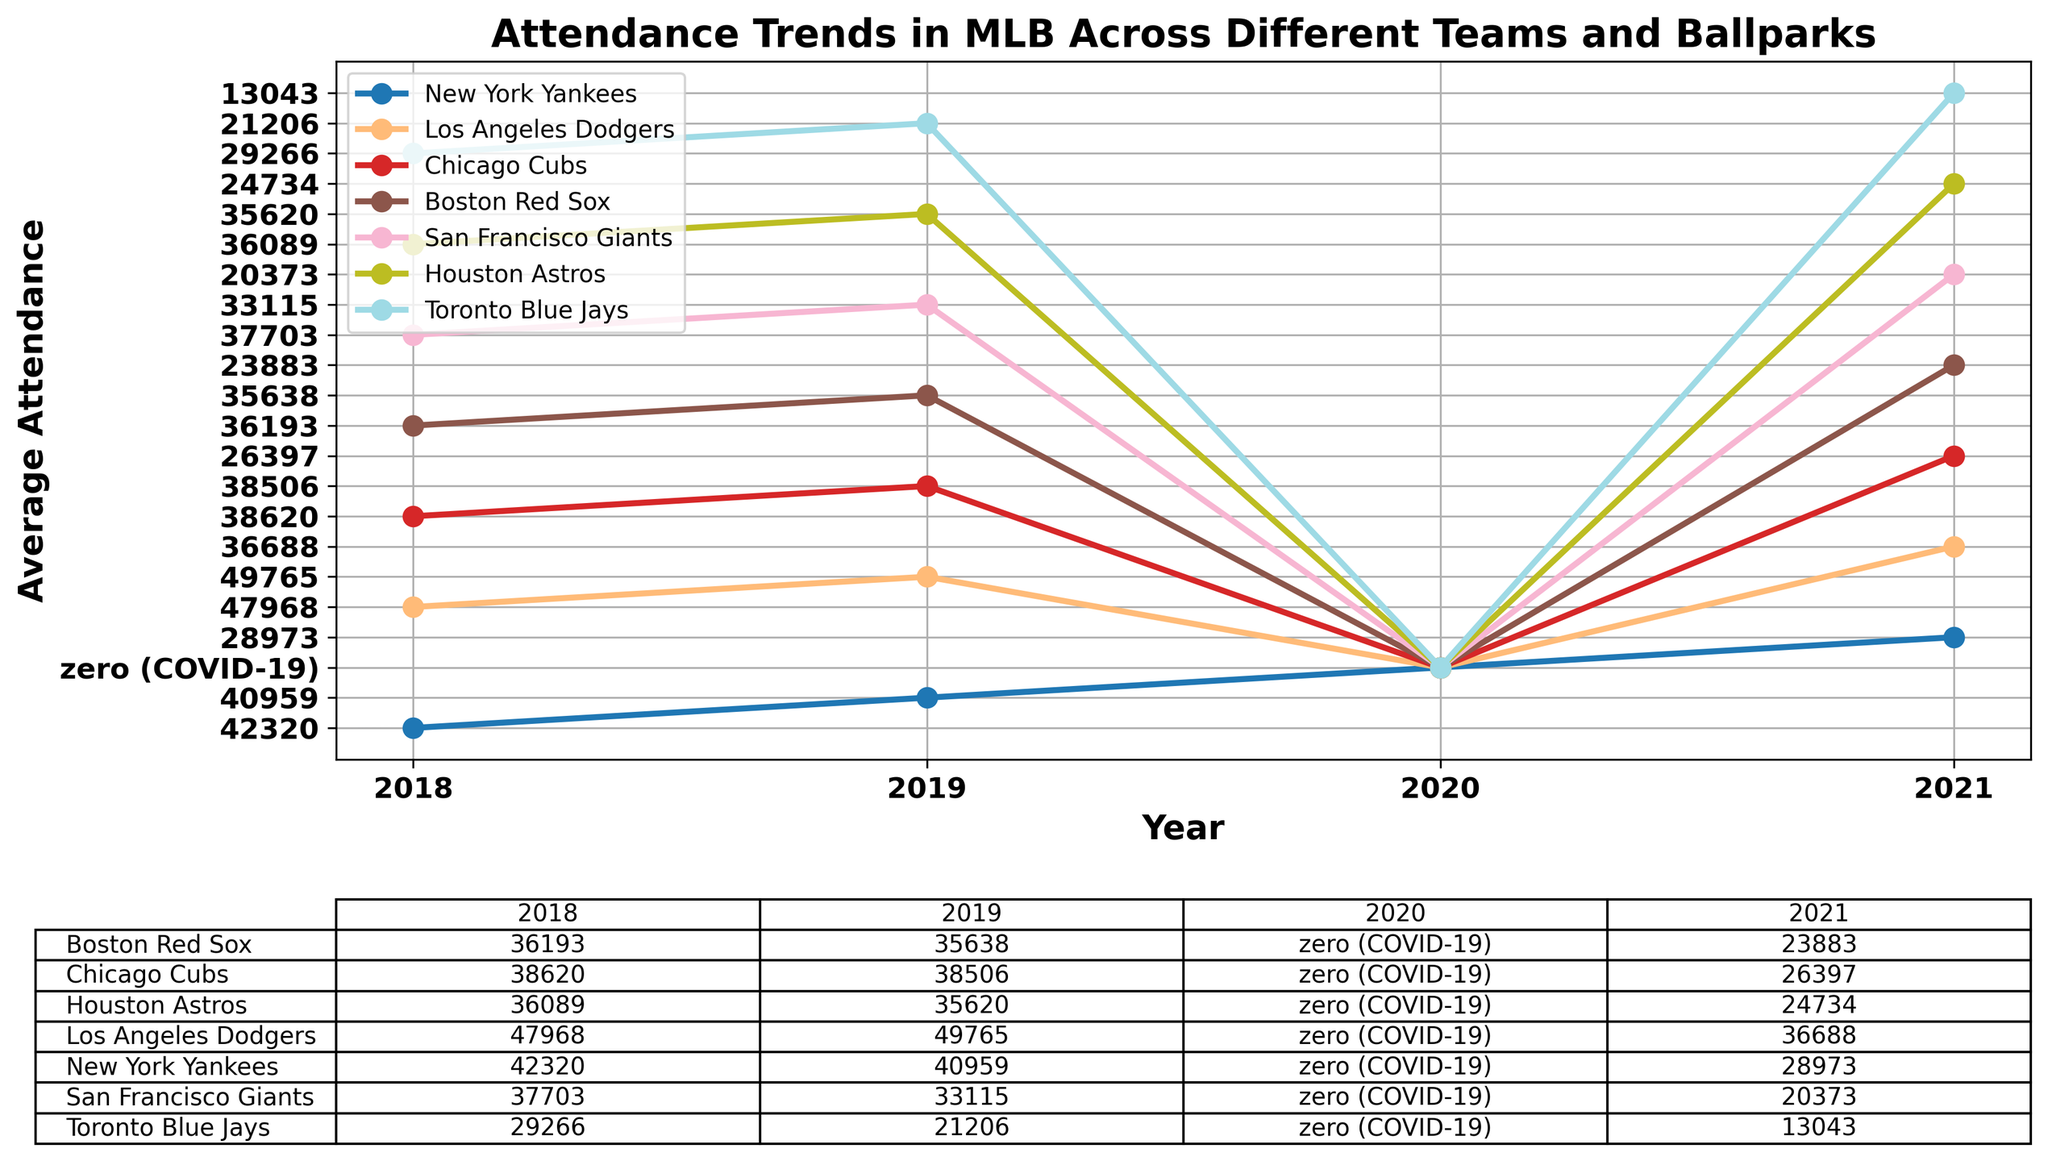What is the general trend in attendance for the Los Angeles Dodgers from 2018 to 2021? The Los Angeles Dodgers had increased attendance from 2018 (47,968) to 2019 (49,765). Attendance dropped to zero in 2020 due to COVID-19 and partially recovered to 36,688 in 2021.
Answer: Increased in 2019, dropped in 2020, partially recovered in 2021 Which team's attendance dropped the most from 2019 to 2021? The New York Yankees had an average attendance of 40,959 in 2019 and 28,973 in 2021, resulting in a drop of 11,986. The Los Angeles Dodgers saw a drop from 49,765 to 36,688, a difference of 13,077. Other teams had smaller differences.
Answer: Los Angeles Dodgers Calculate the total attendance for the New York Yankees from 2018 to 2021, excluding 2020. Sum the attendances of 2018, 2019, and 2021 for the New York Yankees: 42,320 (2018) + 40,959 (2019) + 28,973 (2021) = 112,252.
Answer: 112,252 Which team had the highest average attendance in 2021? By looking at the 2021 data, the Los Angeles Dodgers had the highest average attendance at 36,688.
Answer: Los Angeles Dodgers How did the COVID-19 pandemic affect the attendance trends in 2020? All teams had an average attendance of zero in 2020 due to the COVID-19 pandemic.
Answer: All attendance was zero Compare the average attendance in 2021 between the Boston Red Sox and the San Francisco Giants. In 2021, the Boston Red Sox had an average attendance of 23,883, while the San Francisco Giants had 20,373. The Boston Red Sox had a higher average attendance.
Answer: Boston Red Sox Which team showed the most consistent attendance figures between 2018 and 2019? The Chicago Cubs had 38,620 in 2018 and 38,506 in 2019, showing the smallest variance compared to other teams.
Answer: Chicago Cubs Determine the average attendance trend for the Toronto Blue Jays from 2018 to 2021, excluding 2020. Toronto Blue Jays had 29,266 in 2018, 21,206 in 2019, and 13,043 in 2021. The trend shows a continuous decline in attendance over these years.
Answer: Declining trend Calculate the percentage drop in attendance for the Houston Astros from 2019 to 2021. The attendance dropped from 35,620 in 2019 to 24,734 in 2021. The percentage drop is calculated as ((35,620 - 24,734) / 35,620) * 100 = 30.57%.
Answer: 30.57% 